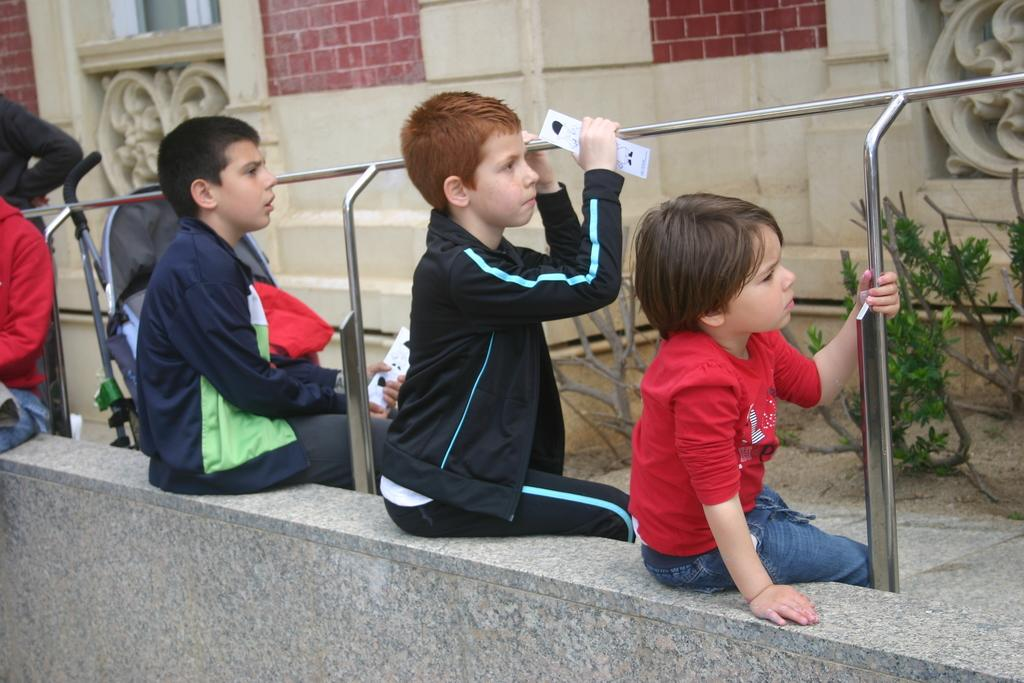What are the people in the image doing? The people in the image are sitting. What are the people holding in the image? The people are holding objects. What type of vegetation can be seen in the image? There are plants in the image. What type of structure is visible in the image? There is a building in the image. What type of hose is being used to create the destruction in the image? There is no hose or destruction present in the image. What type of prose is being recited by the people in the image? There is no indication of any prose being recited in the image. 